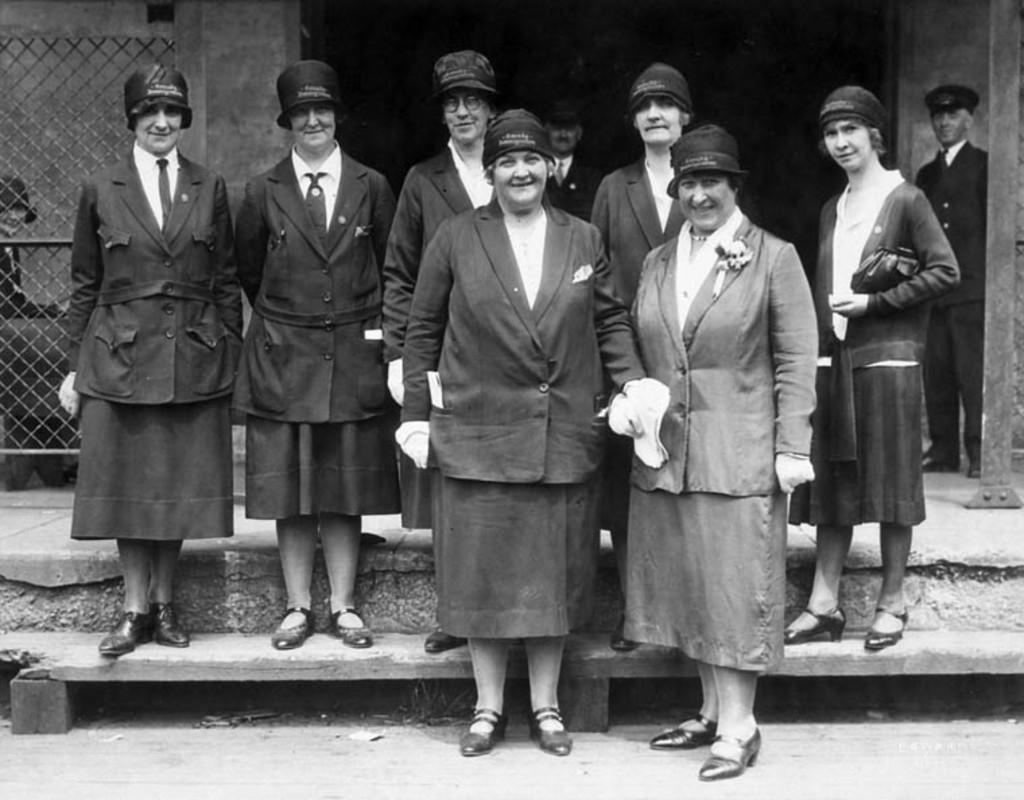What are the people in the foreground of the image doing? The people in the foreground of the image are standing and posing to the camera. What can be seen in the background of the image? There is fencing and a pillar in the background of the image. How many people are visible in the background of the image? There are three people in the background of the image. What type of hole can be seen in the image? There is no hole present in the image. Is there a church visible in the image? There is no church present in the image. 